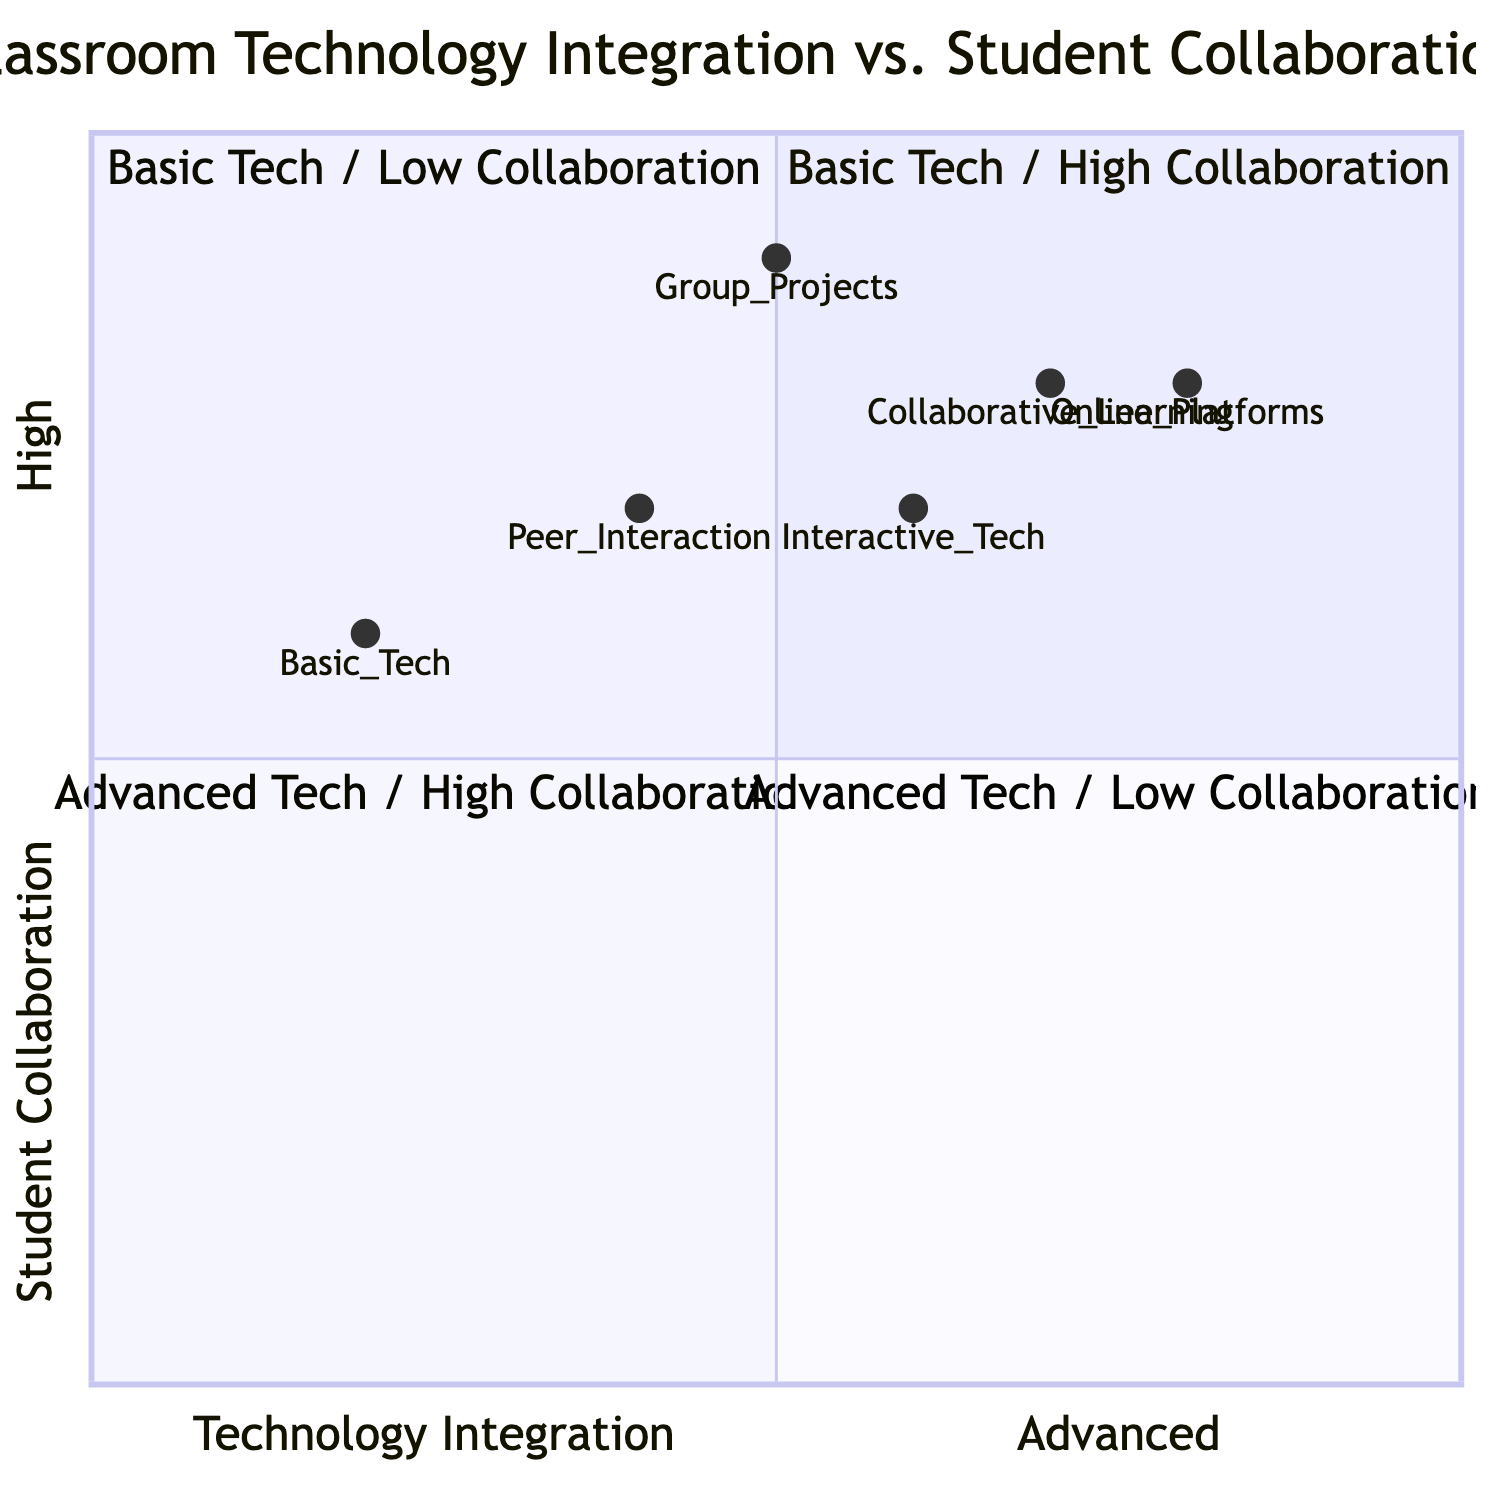What quadrant represents Basic Technology Integration with High Student Collaboration? The diagram shows that Quadrant 1 corresponds to Basic Technology Integration and High Student Collaboration.
Answer: Quadrant 1 Which technology level has the highest collaboration score? By examining the values, Online Platforms have the highest collaboration score at 0.8, indicating strong collaboration.
Answer: Online Platforms What is the student collaboration score for Group Projects? The score for Group Projects is represented as [0.5, 0.9], indicating a high level of collaboration at 0.9.
Answer: 0.9 How many types of technology integration are represented in the diagram? The diagram lists three technology levels: Basic Tech, Interactive Tech, and Online Platforms, indicating three types.
Answer: Three Which quadrant has Advanced Technology Integration and Low Student Collaboration? The diagram identifies Quadrant 4 as the area representing Advanced Technology Integration coupled with Low Student Collaboration.
Answer: Quadrant 4 What is the value associated with Interactive Technology in the collaboration metric? Looking at Interactive Technology's coordinates of [0.6, 0.7], the collaboration metric score is 0.7.
Answer: 0.7 In which quadrant is Collaborative Learning located based on its values? The coordinates for Collaborative Learning are [0.7, 0.8]; it falls into Quadrant 3, which is High Collaboration and Advanced Technology Integration.
Answer: Quadrant 3 What collaboration metric score is associated with Peer Interaction? The Peer Interaction score is represented as [0.4, 0.7], where the collaboration metric is 0.7.
Answer: 0.7 Which technology integration type involves the use of online learning management systems? The data specifies that Online Platforms involve utilizing LMS, indicating this technology type.
Answer: Online Platforms 